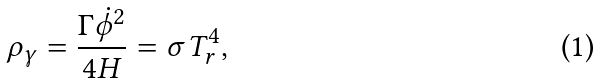<formula> <loc_0><loc_0><loc_500><loc_500>\rho _ { \gamma } = \frac { \Gamma \dot { \phi } ^ { 2 } } { 4 H } = \sigma T _ { r } ^ { 4 } ,</formula> 